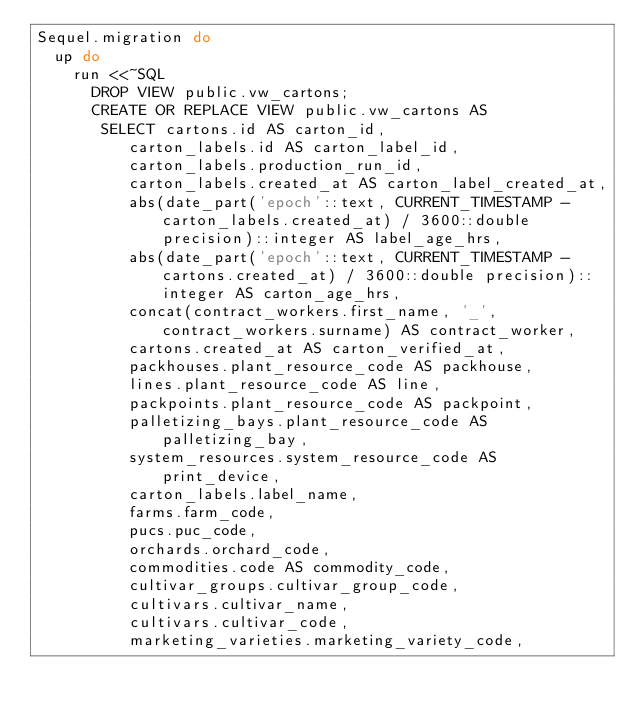Convert code to text. <code><loc_0><loc_0><loc_500><loc_500><_Ruby_>Sequel.migration do
  up do
    run <<~SQL
      DROP VIEW public.vw_cartons;
      CREATE OR REPLACE VIEW public.vw_cartons AS
       SELECT cartons.id AS carton_id,
          carton_labels.id AS carton_label_id,
          carton_labels.production_run_id,
          carton_labels.created_at AS carton_label_created_at,
          abs(date_part('epoch'::text, CURRENT_TIMESTAMP - carton_labels.created_at) / 3600::double precision)::integer AS label_age_hrs,
          abs(date_part('epoch'::text, CURRENT_TIMESTAMP - cartons.created_at) / 3600::double precision)::integer AS carton_age_hrs,
          concat(contract_workers.first_name, '_', contract_workers.surname) AS contract_worker,
          cartons.created_at AS carton_verified_at,
          packhouses.plant_resource_code AS packhouse,
          lines.plant_resource_code AS line,
          packpoints.plant_resource_code AS packpoint,
          palletizing_bays.plant_resource_code AS palletizing_bay,
          system_resources.system_resource_code AS print_device,
          carton_labels.label_name,
          farms.farm_code,
          pucs.puc_code,
          orchards.orchard_code,
          commodities.code AS commodity_code,
          cultivar_groups.cultivar_group_code,
          cultivars.cultivar_name,
          cultivars.cultivar_code,
          marketing_varieties.marketing_variety_code,</code> 